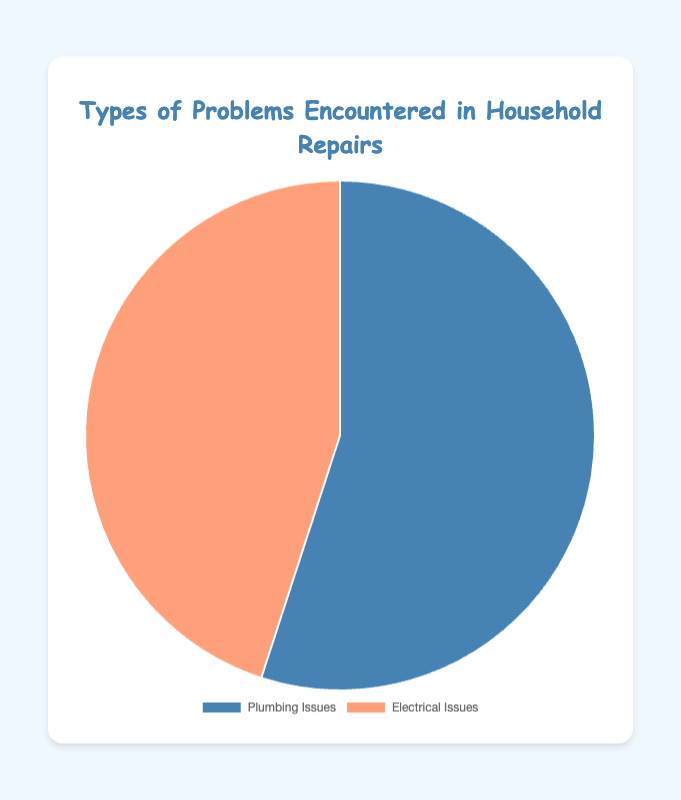What types of issues are more common, plumbing or electrical? The chart shows two categories, Plumbing Issues and Electrical Issues. The larger portion is Plumbing Issues at 55%, while Electrical Issues is at 45%. Thus, plumbing issues are more common.
Answer: Plumbing Issues How many percentage points more common are plumbing issues compared to electrical issues? To calculate the difference in percentage points, subtract the percentage of Electrical Issues (45%) from the percentage of Plumbing Issues (55%). 55% - 45% = 10%.
Answer: 10 percentage points What is the ratio of plumbing issues to electrical issues? To find the ratio, divide the percentage of Plumbing Issues (55%) by the percentage of Electrical Issues (45%). 55 / 45 simplifies to 11 / 9 or approximately 1.22:1.
Answer: 1.22:1 If these percentages were applied to 200 household repair issues, how many would be plumbing issues? To find this, multiply 200 by the percentage of Plumbing Issues (55%). 200 * 0.55 equals 110. So, there would be 110 plumbing issues.
Answer: 110 Is the proportion of plumbing issues greater than half of the total issues? The chart shows that Plumbing Issues account for 55% of the total. Since 55% is greater than half (50%), the proportion of plumbing issues is indeed greater than half.
Answer: Yes Compare the visual size of the segments representing plumbing and electrical issues. Which one is larger? By observing the chart, the segment representing Plumbing Issues is visually larger than the one for Electrical Issues. This corresponds to the higher percentage of 55% for Plumbing Issues compared to 45% for Electrical Issues.
Answer: Plumbing Issues If 100 more reports were added evenly to both plumbing and electrical issues, what would the new percentages be? If both categories receive 100 additional reports, their percentages will remain the same because their relative proportions do not change. Plumbing Issues would still be 55%, and Electrical Issues would still be 45%.
Answer: Plumbing: 55%, Electrical: 45% What could be a possible reason for having a higher percentage of plumbing issues compared to electrical issues? Plumbing problems such as leaks, clogs, and broken pipes might be more common due to regular use and wear and tear, whereas electrical issues may not surface as frequently because electrical systems typically require less frequent maintenance.
Answer: More frequent wear and tear on plumbing systems 